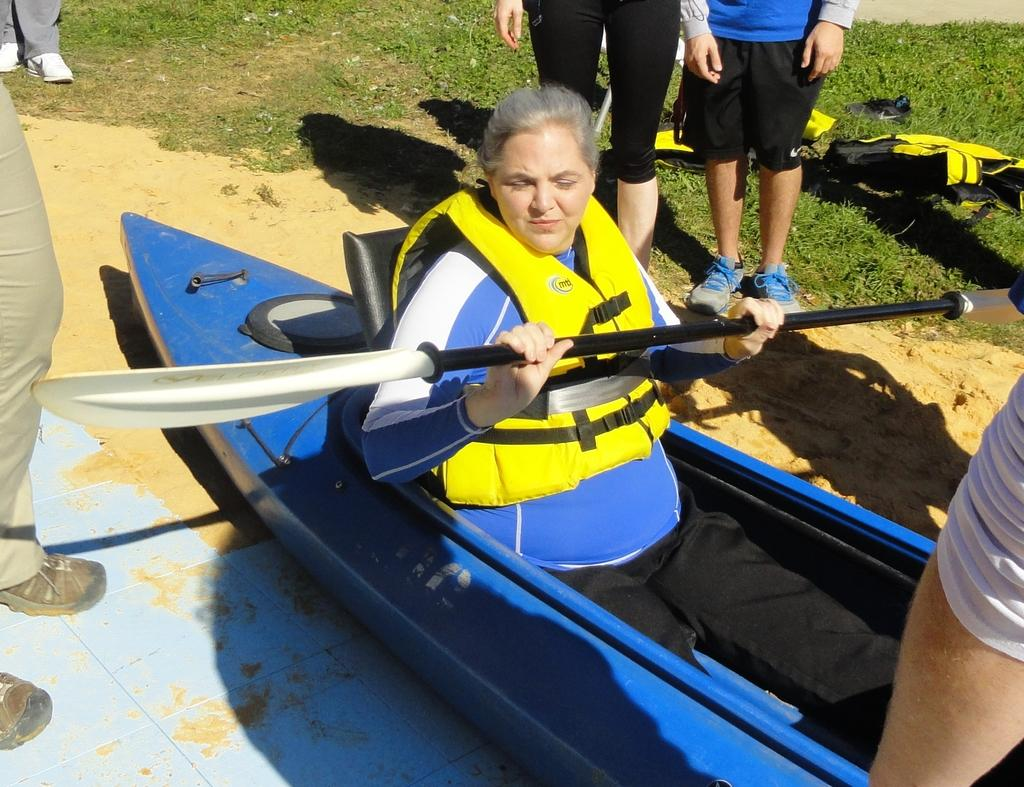What is the person in the image doing? The person is sitting on a boat and holding a paddle. Are there any other people in the image? Yes, there are other people in the image. What can be seen in the background of the image? There is grass visible in the image. What type of ornament is hanging from the paddle in the image? There is no ornament hanging from the paddle in the image. Can you tell me how many bananas are visible in the image? There are no bananas present in the image. 